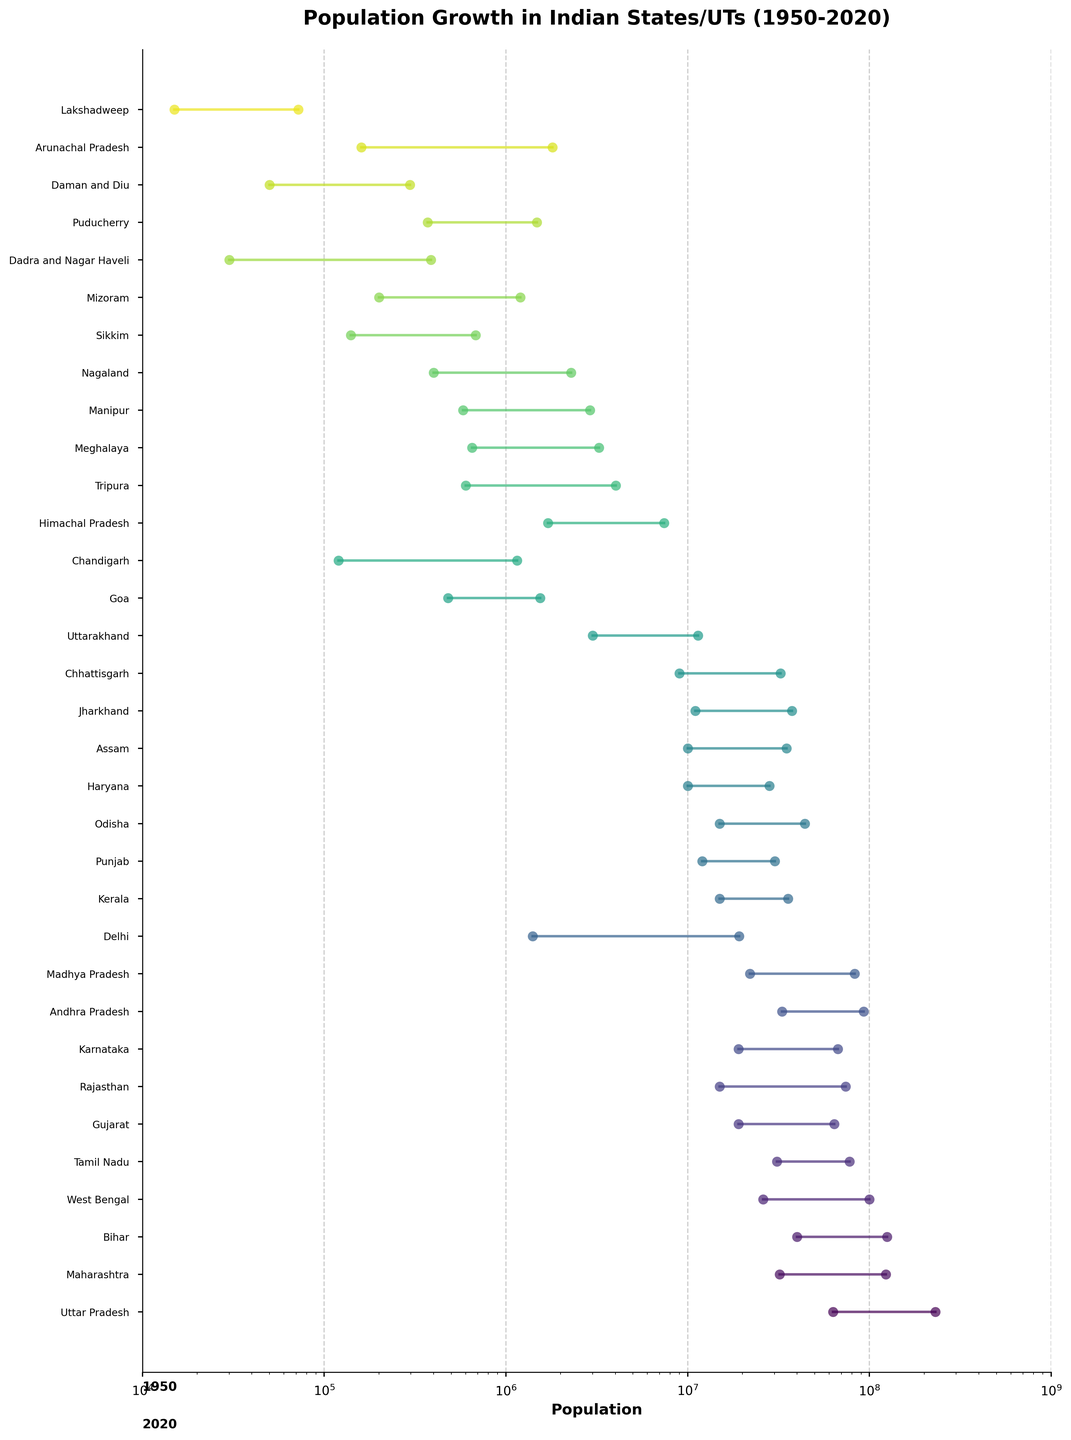What is the title of the plot? The title is located at the top of the figure. It provides an overview of the data being visualized.
Answer: Population Growth in Indian States/UTs (1950-2020) How many states and union territories are represented in the plot? Count the number of points where the state or union territory names are shown on the y-axis.
Answer: 31 Which state had the highest population in 2020? Look at the rightmost end of the lines connecting the dots for each state and identify which one's endpoint is the highest relative to the x-axis.
Answer: Uttar Pradesh Which state had a population of around 680,000 in 1950? Find the year 1950 on the plot and identify the state that intersects with approximately 680,000 on the x-axis.
Answer: Sikkim What is the population growth of Tamil Nadu from 1950 to 2020? Identify Tamil Nadu, track its 1950 population and 2020 population, then calculate the difference: 77,800,000 - 31,000,000.
Answer: 46,800,000 Which state had a log-scaled population of about 10^6 both in 1950 and 2020? Look for states where both 1950 and 2020 data points are around 1,000,000 on the x-axis.
Answer: Mizoram Which state or union territory showed the highest relative growth between 1950 and 2020? Compare the differences between the 1950 and 2020 populations for each state; the state with the largest difference shows the highest growth.
Answer: Maharashtra What is the population range of Maharashtra as seen in the plot? Look at the range between the 1950 population point and the 2020 population point on the plot.
Answer: 32,000,000 to 123,000,000 Which states had a population of less than 1 million in 1950? Identify all the states where the 1950 population points are below the 1,000,000 mark on the x-axis.
Answer: Chandigarh, Goa, Lakshadweep, Mizoram, Nagaland, Sikkim, Daman and Diu, Puducherry, Dadra and Nagar Haveli, Arunachal Pradesh Which two states or union territories showed the closest population figures in 2020? Compare the population figures shown in 2020 for each state to find the two closest values.
Answer: Tripura and Arunachal Pradesh 